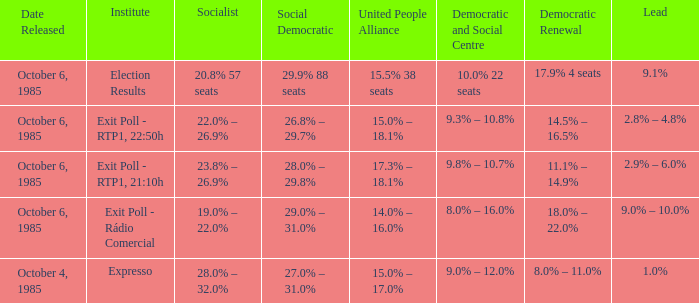What were the institutes that assigned a 18.0% - 22.0% score for democratic renewal in an october 6, 1985 poll? Exit Poll - Rádio Comercial. Could you help me parse every detail presented in this table? {'header': ['Date Released', 'Institute', 'Socialist', 'Social Democratic', 'United People Alliance', 'Democratic and Social Centre', 'Democratic Renewal', 'Lead'], 'rows': [['October 6, 1985', 'Election Results', '20.8% 57 seats', '29.9% 88 seats', '15.5% 38 seats', '10.0% 22 seats', '17.9% 4 seats', '9.1%'], ['October 6, 1985', 'Exit Poll - RTP1, 22:50h', '22.0% – 26.9%', '26.8% – 29.7%', '15.0% – 18.1%', '9.3% – 10.8%', '14.5% – 16.5%', '2.8% – 4.8%'], ['October 6, 1985', 'Exit Poll - RTP1, 21:10h', '23.8% – 26.9%', '28.0% – 29.8%', '17.3% – 18.1%', '9.8% – 10.7%', '11.1% – 14.9%', '2.9% – 6.0%'], ['October 6, 1985', 'Exit Poll - Rádio Comercial', '19.0% – 22.0%', '29.0% – 31.0%', '14.0% – 16.0%', '8.0% – 16.0%', '18.0% – 22.0%', '9.0% – 10.0%'], ['October 4, 1985', 'Expresso', '28.0% – 32.0%', '27.0% – 31.0%', '15.0% – 17.0%', '9.0% – 12.0%', '8.0% – 11.0%', '1.0%']]} 